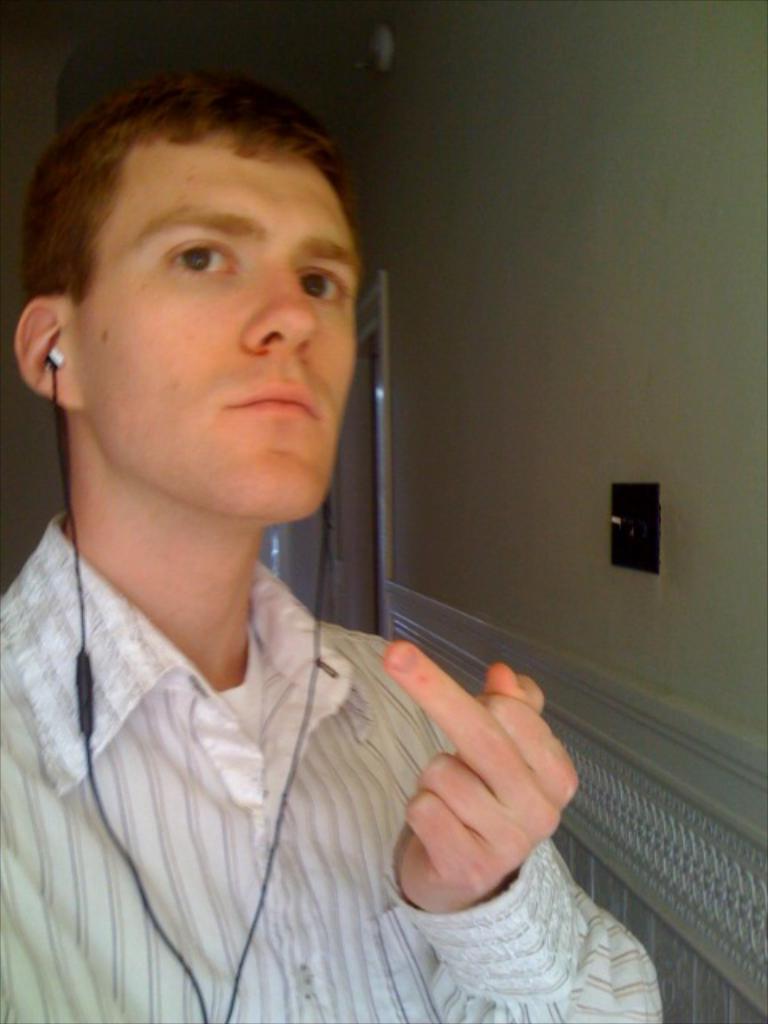Could you give a brief overview of what you see in this image? In the image there is a man in the foreground, he is wearing earphones and behind the man there is a wall. 